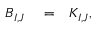Convert formula to latex. <formula><loc_0><loc_0><loc_500><loc_500>\begin{array} { r l r } { B _ { I , J } } & = } & { K _ { I , J } , } \end{array}</formula> 